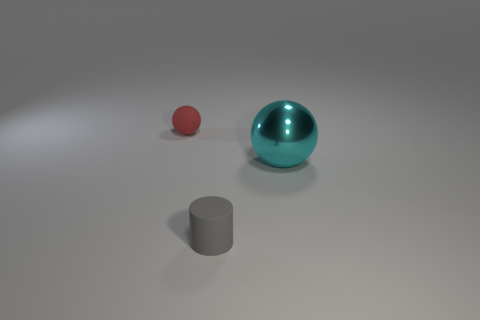Add 3 gray cylinders. How many objects exist? 6 Subtract all cylinders. How many objects are left? 2 Subtract all big cyan things. Subtract all rubber cylinders. How many objects are left? 1 Add 2 cylinders. How many cylinders are left? 3 Add 3 large cyan things. How many large cyan things exist? 4 Subtract 0 green cylinders. How many objects are left? 3 